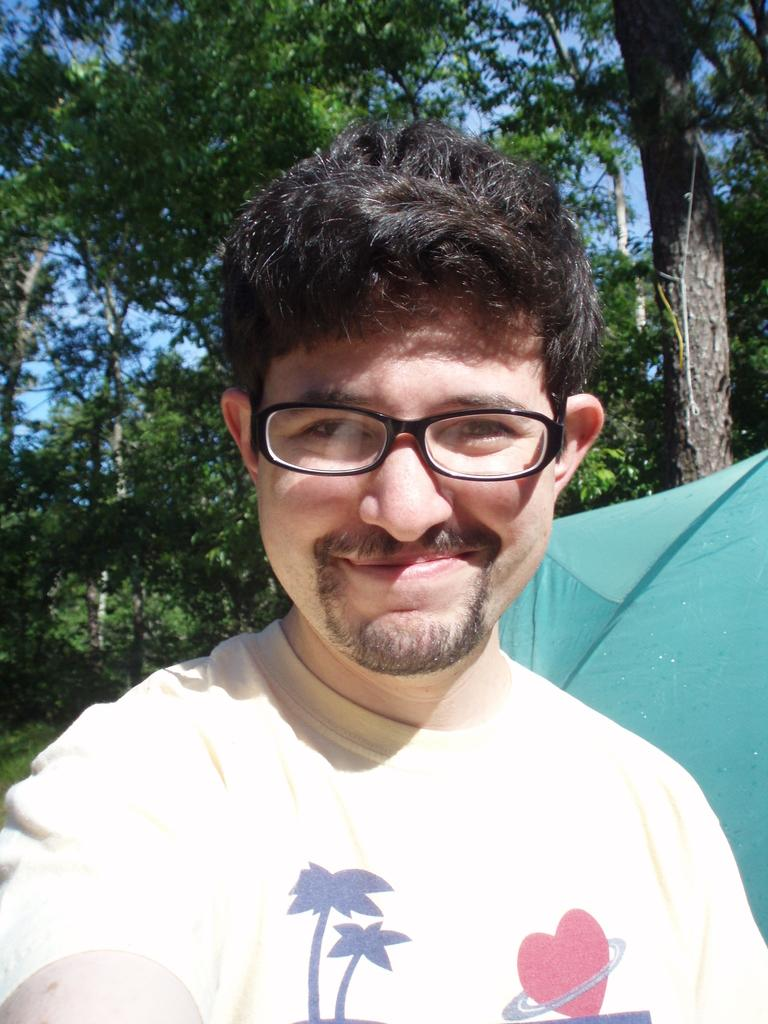Who is present in the image? There is a man in the image. What is the man doing in the image? The man is smiling in the image. What accessory is the man wearing? The man is wearing spectacles in the image. What can be seen in the background of the image? There are trees in the background of the image. What type of wire is the man holding in the image? There is no wire present in the image; the man is simply smiling and wearing spectacles. 